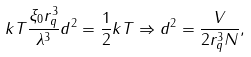Convert formula to latex. <formula><loc_0><loc_0><loc_500><loc_500>k T \frac { \xi _ { 0 } r _ { q } ^ { 3 } } { \lambda ^ { 3 } } d ^ { 2 } = \frac { 1 } { 2 } k T \Rightarrow d ^ { 2 } = \frac { V } { 2 r _ { q } ^ { 3 } N } ,</formula> 